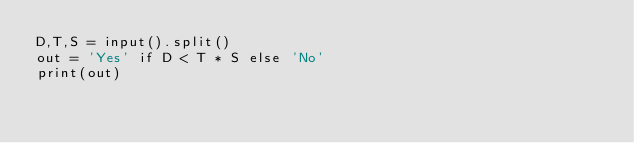Convert code to text. <code><loc_0><loc_0><loc_500><loc_500><_Python_>D,T,S = input().split()
out = 'Yes' if D < T * S else 'No'
print(out)</code> 